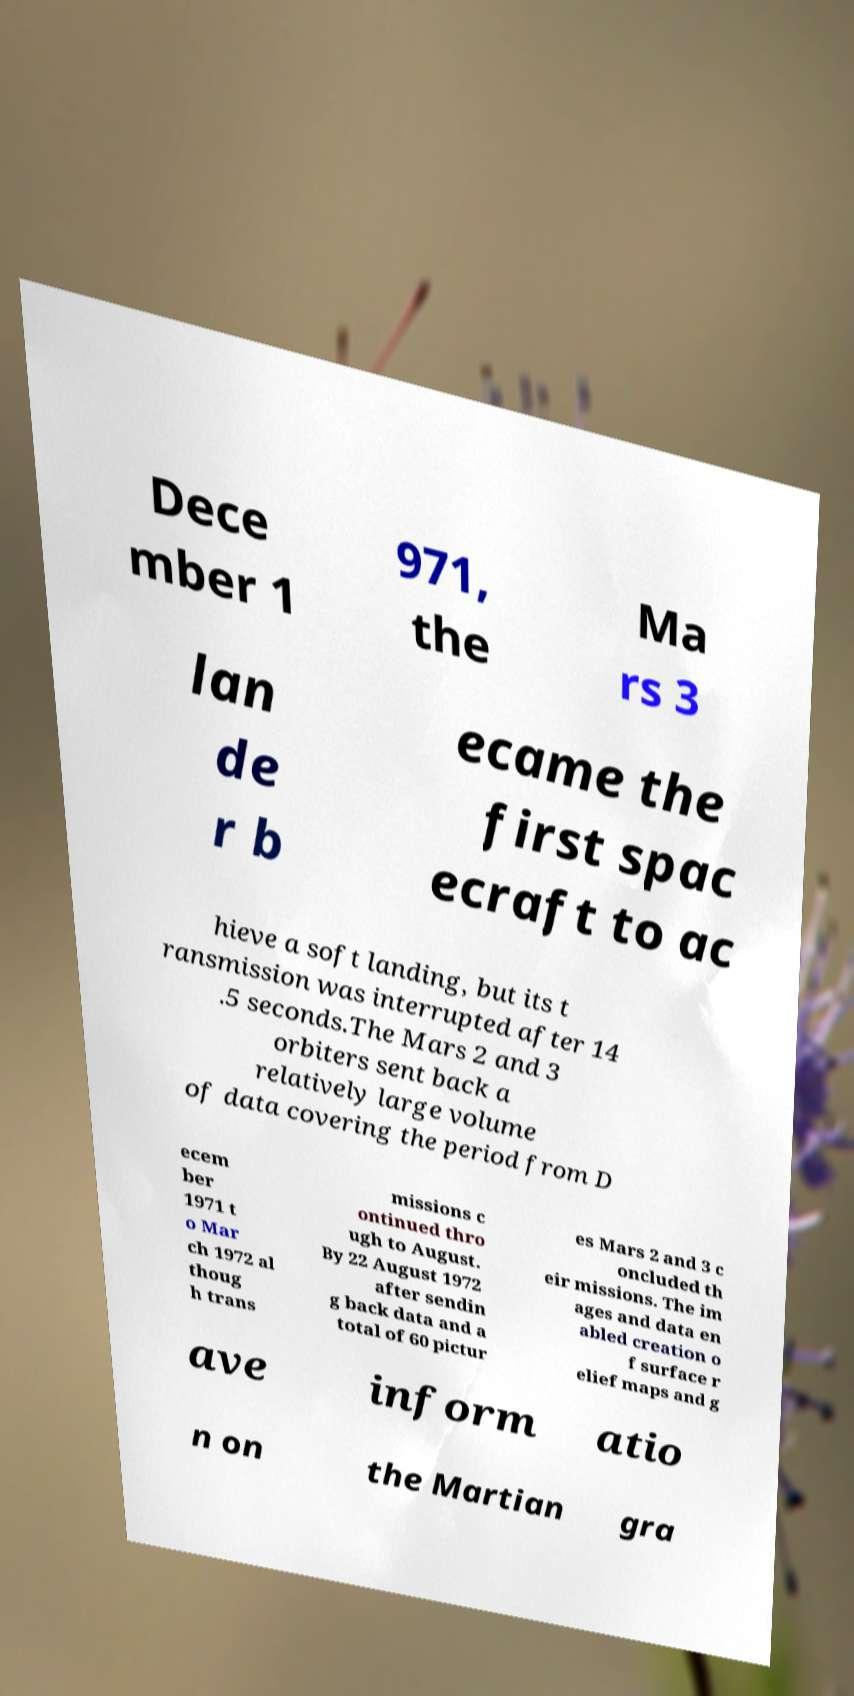Can you accurately transcribe the text from the provided image for me? Dece mber 1 971, the Ma rs 3 lan de r b ecame the first spac ecraft to ac hieve a soft landing, but its t ransmission was interrupted after 14 .5 seconds.The Mars 2 and 3 orbiters sent back a relatively large volume of data covering the period from D ecem ber 1971 t o Mar ch 1972 al thoug h trans missions c ontinued thro ugh to August. By 22 August 1972 after sendin g back data and a total of 60 pictur es Mars 2 and 3 c oncluded th eir missions. The im ages and data en abled creation o f surface r elief maps and g ave inform atio n on the Martian gra 